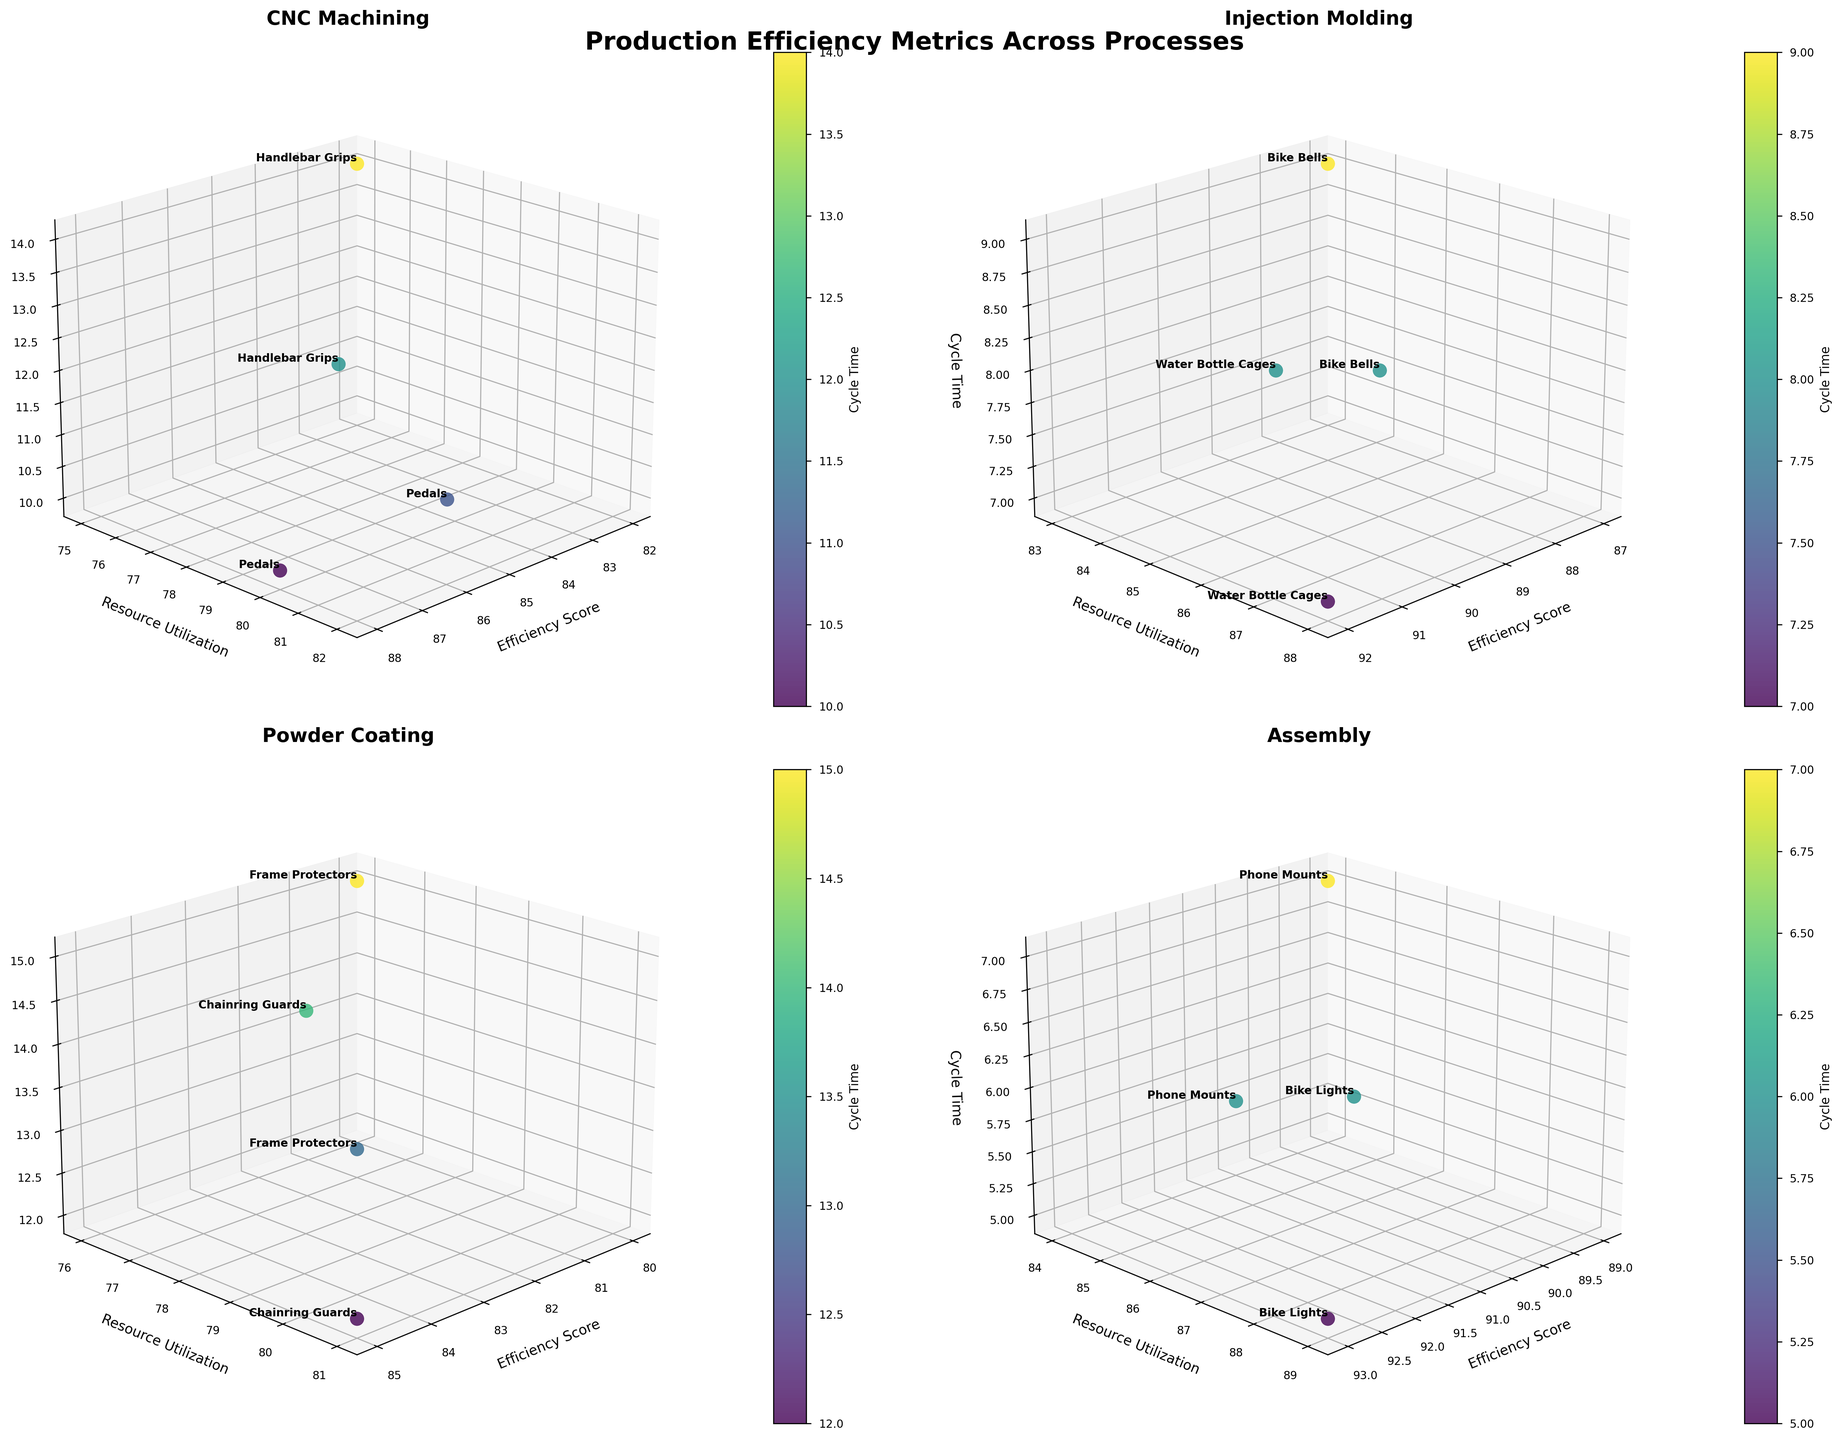What process has the highest efficiency score for Bike Lights? Based on the subplot for the Assembly process, Bike Lights in Austin has an efficiency score of 93, which is the highest for this product among all processes.
Answer: Assembly Which product has the shortest cycle time in Injection Molding? From the subplot for Injection Molding, Water Bottle Cages in Austin have the shortest cycle time of 7.
Answer: Water Bottle Cages Compare the resource utilization for Handlebar Grips in Detroit for CNC Machining and Injection Molding. Which is higher? Handlebar Grips are only produced using CNC Machining and have a resource utilization of 78 in Detroit. Injection Molding does not produce Handlebar Grips.
Answer: CNC Machining What is the difference in efficiency score between Phone Mounts in Austin and Detroit in the Assembly process? In the Assembly process subplot, the efficiency score is 92 for Austin and 89 for Detroit. The difference is 92 - 89 = 3.
Answer: 3 Identify the facility location with the highest cycle time for Powder Coating. In the Powder Coating subplot, Frame Protectors in Detroit have the highest cycle time of 15.
Answer: Detroit Which process has the lowest resource utilization for products in Austin? In the CNC Machining subplot, Handlebar Grips have a resource utilization of 75, which is the lowest among all products in Austin.
Answer: CNC Machining How many different products are visualized for Injection Molding? Injection Molding subplot shows three products: Water Bottle Cages, Bike Bells, and Frame Protectors.
Answer: 3 Which product in the Assembly process has the highest efficiency score and where is it located? The Assembly subplot shows that Bike Lights in Austin have the highest efficiency score of 93.
Answer: Bike Lights, Austin Compare the cycle times of Pedals between Detroit and Austin in the CNC Machining process. In the CNC Machining subplot, the cycle time for Pedals is 10 in Detroit and 11 in Austin. The cycle time is lower in Detroit.
Answer: Detroit What is the average efficiency score for Powder Coating products produced in Austin? Powder Coating subplot in Austin shows three products with efficiency scores: Frame Protectors (83), Chainring Guards (85). The average is (83 + 85) / 2 = 84.
Answer: 84 